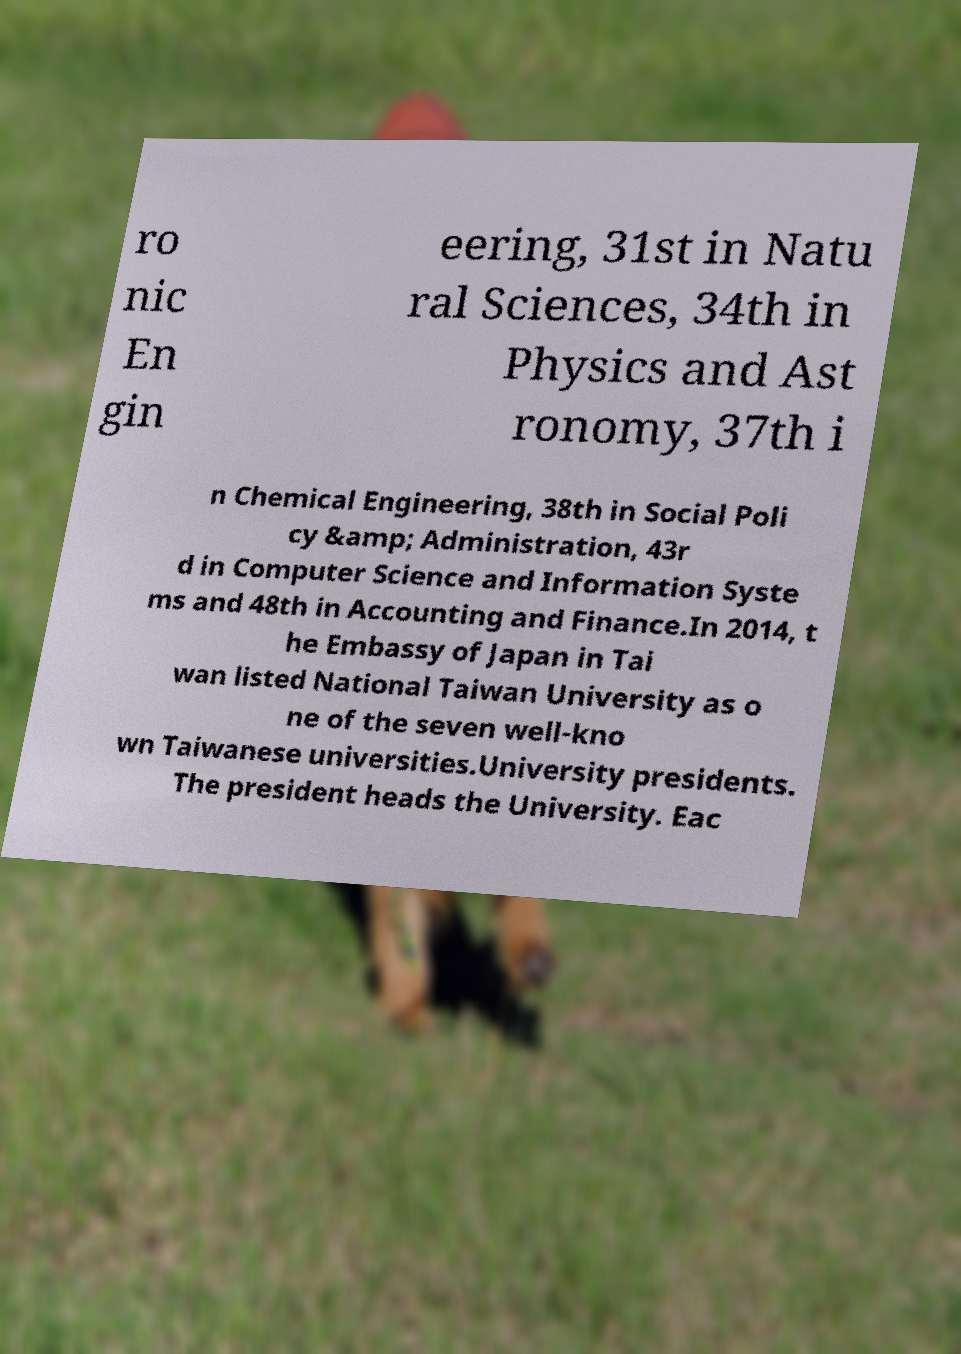There's text embedded in this image that I need extracted. Can you transcribe it verbatim? ro nic En gin eering, 31st in Natu ral Sciences, 34th in Physics and Ast ronomy, 37th i n Chemical Engineering, 38th in Social Poli cy &amp; Administration, 43r d in Computer Science and Information Syste ms and 48th in Accounting and Finance.In 2014, t he Embassy of Japan in Tai wan listed National Taiwan University as o ne of the seven well-kno wn Taiwanese universities.University presidents. The president heads the University. Eac 